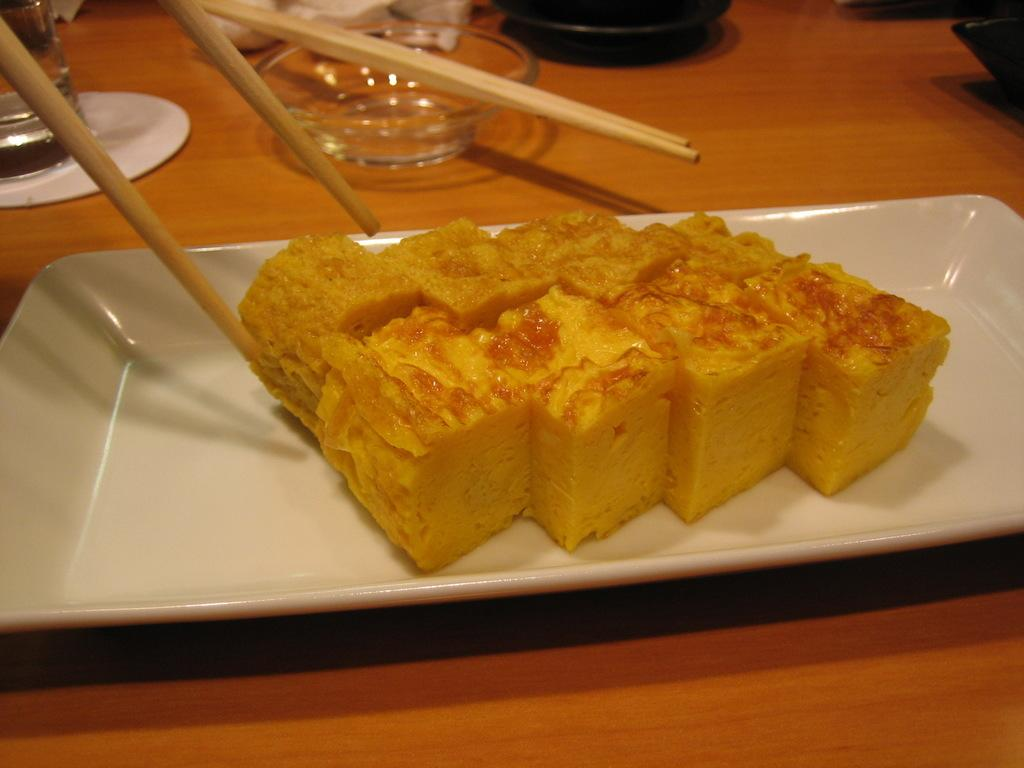What piece of furniture is present in the image? There is a table in the image. What is placed on the table? There is a plate, a bowl, a glass, and chopsticks on the table. What is in the plate on the table? There is food in the plate. What might be used for drinking in the image? There is a glass on the table that might be used for drinking. What type of punishment is being administered in the image? There is no punishment being administered in the image; it features a table with various items on it. What type of ship can be seen sailing in the background of the image? There is no ship visible in the image; it only shows a table with objects on it. 